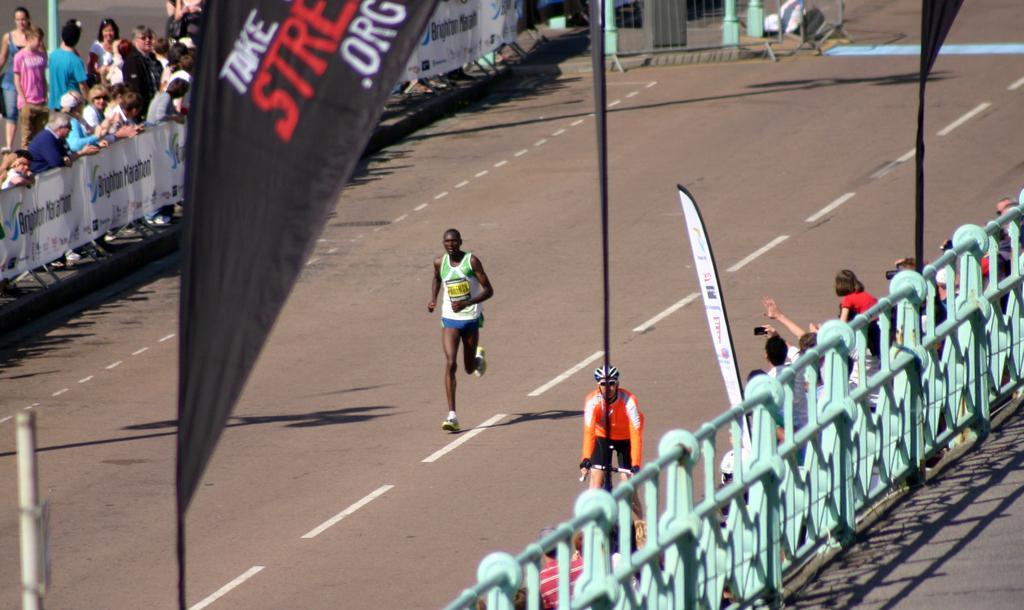Can you describe this image briefly? In the foreground of the picture we can see poles, flags, people, bicycle and road. In the middle of the picture we can see a person running on the road. At the top left corner we can see people, banner, railing, poles and other objects. 